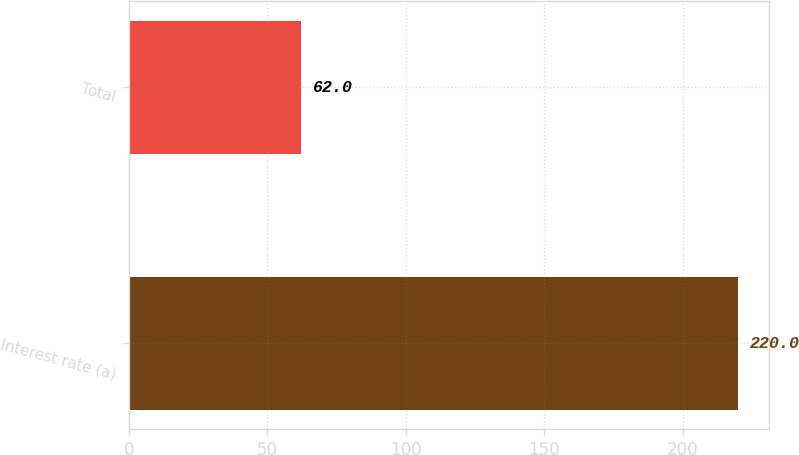Convert chart. <chart><loc_0><loc_0><loc_500><loc_500><bar_chart><fcel>Interest rate (a)<fcel>Total<nl><fcel>220<fcel>62<nl></chart> 